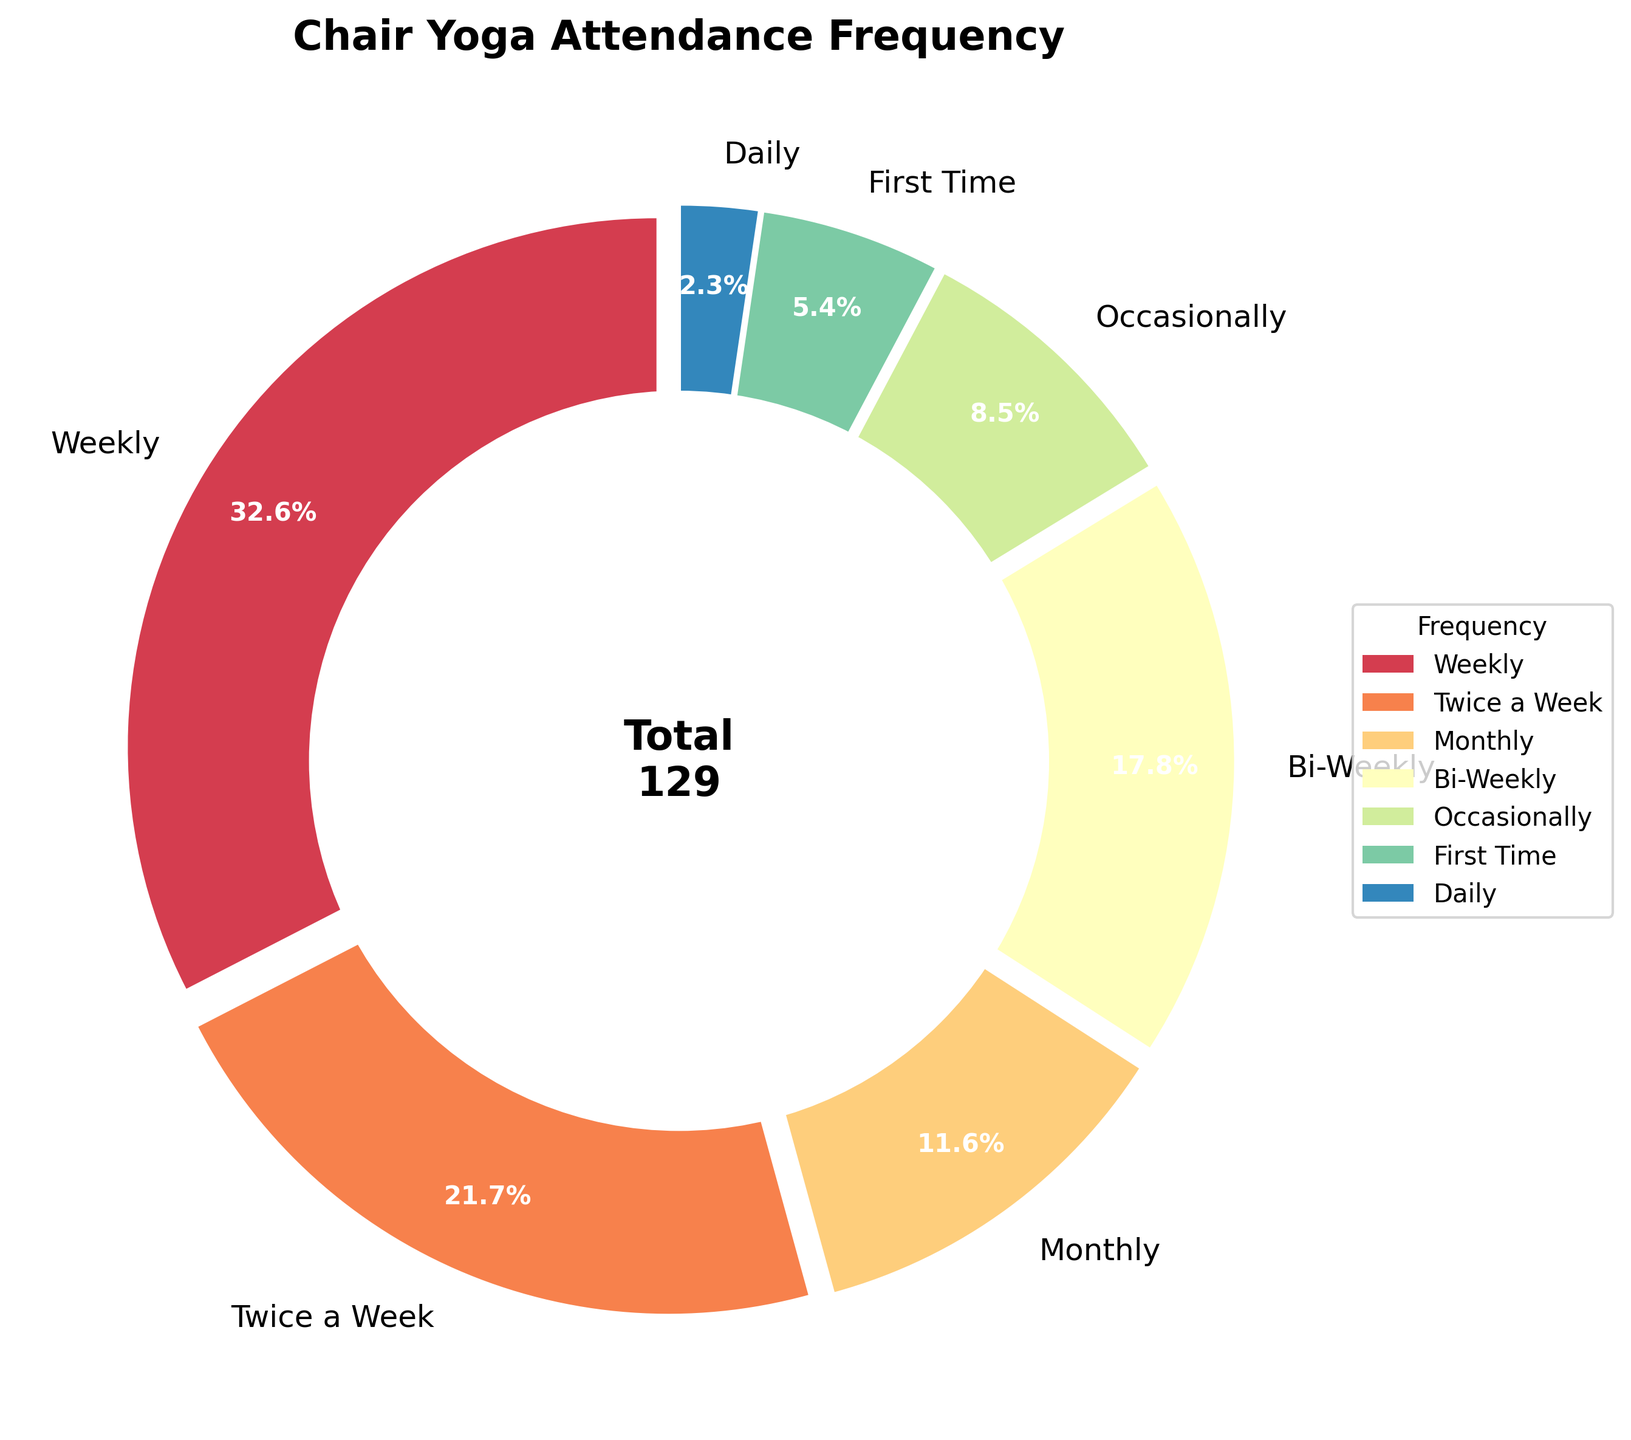Which attendance frequency has the highest number of patients? The chart shows that the 'Weekly' category has the largest slice. By looking at the labels, 'Weekly' has 42 patients, which is the highest number.
Answer: Weekly What percentage of patients attend chair yoga twice a week? The pie chart indicates percentages within the figure. The 'Twice a Week' segment specifically shows 21.1%.
Answer: 21.1% How many more patients attend chair yoga weekly compared to bi-weekly? The pie chart provides the number of patients for each frequency. Weekly has 42 patients, and Bi-Weekly has 23. Subtracting these gives 42 - 23 = 19.
Answer: 19 Which attendance frequency has the smallest number of patients, and how many patients are there? The pie chart shows that the 'Daily' segment is the smallest. The label shows 3 patients.
Answer: Daily, 3 How many patients attend chair yoga during the month (Weekly + Bi-Weekly + Monthly)? The figure shows the counts for each category. Adding Weekly (42), Bi-Weekly (23), and Monthly (15) gives 42 + 23 + 15 = 80.
Answer: 80 Compare the number of patients attending chair yoga weekly and attending for the first time. How many times larger is the former? From the pie chart, Weekly has 42 patients, and First Time has 7. Dividing these gives 42 / 7 = 6.
Answer: 6 times What proportion of patients attend chair yoga occasionally compared to those who attend monthly? The chart shows 11 patients occasionally and 15 monthly. Dividing these gives 11 / 15 ≈ 0.73, which is approximately 73%.
Answer: 73% If another 10 patients start attending daily, what would be the new percentage for the daily attendance? Currently, daily has 3 patients. Adding 10 makes 13 patients. The total number of patients is 129. The new percentage is (13 / 129) * 100 ≈ 10.1%.
Answer: 10.1% What is the median number of patients across all attendance frequencies? By ordering the counts: 3, 7, 11, 15, 23, 28, 42, the median is the middle value, which is 15.
Answer: 15 Which segment has the third-largest number of patients, and how many patients does it include? The chart shows the patient numbers: Weekly (42), Twice a Week (28), Bi-Weekly (23), Monthly (15), Occasionally (11), First Time (7), Daily (3). The third-largest is Bi-Weekly with 23 patients.
Answer: Bi-Weekly, 23 